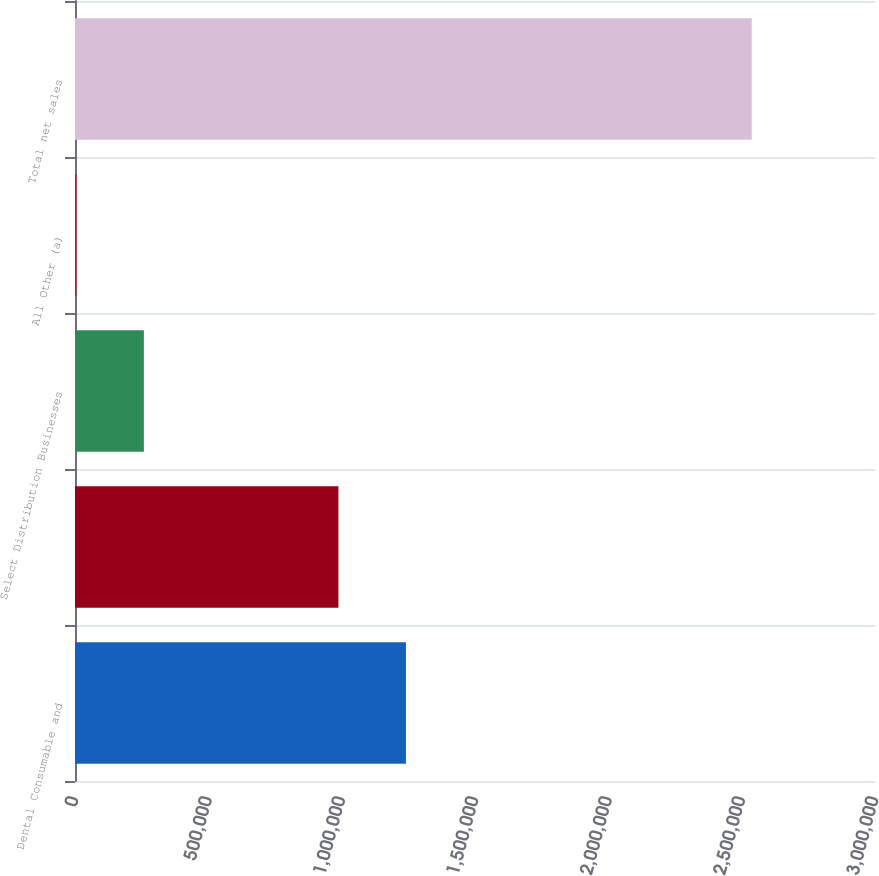Convert chart to OTSL. <chart><loc_0><loc_0><loc_500><loc_500><bar_chart><fcel>Dental Consumable and<fcel>Unnamed: 1<fcel>Select Distribution Businesses<fcel>All Other (a)<fcel>Total net sales<nl><fcel>1.24105e+06<fcel>987778<fcel>258299<fcel>5030<fcel>2.53772e+06<nl></chart> 